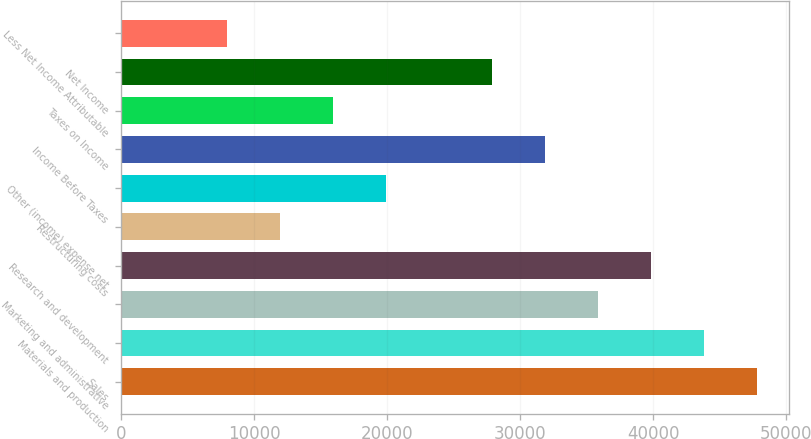Convert chart to OTSL. <chart><loc_0><loc_0><loc_500><loc_500><bar_chart><fcel>Sales<fcel>Materials and production<fcel>Marketing and administrative<fcel>Research and development<fcel>Restructuring costs<fcel>Other (income) expense net<fcel>Income Before Taxes<fcel>Taxes on Income<fcel>Net Income<fcel>Less Net Income Attributable<nl><fcel>47768.1<fcel>43787.6<fcel>35826.4<fcel>39807<fcel>11943.1<fcel>19904.2<fcel>31845.9<fcel>15923.6<fcel>27865.3<fcel>7962.53<nl></chart> 